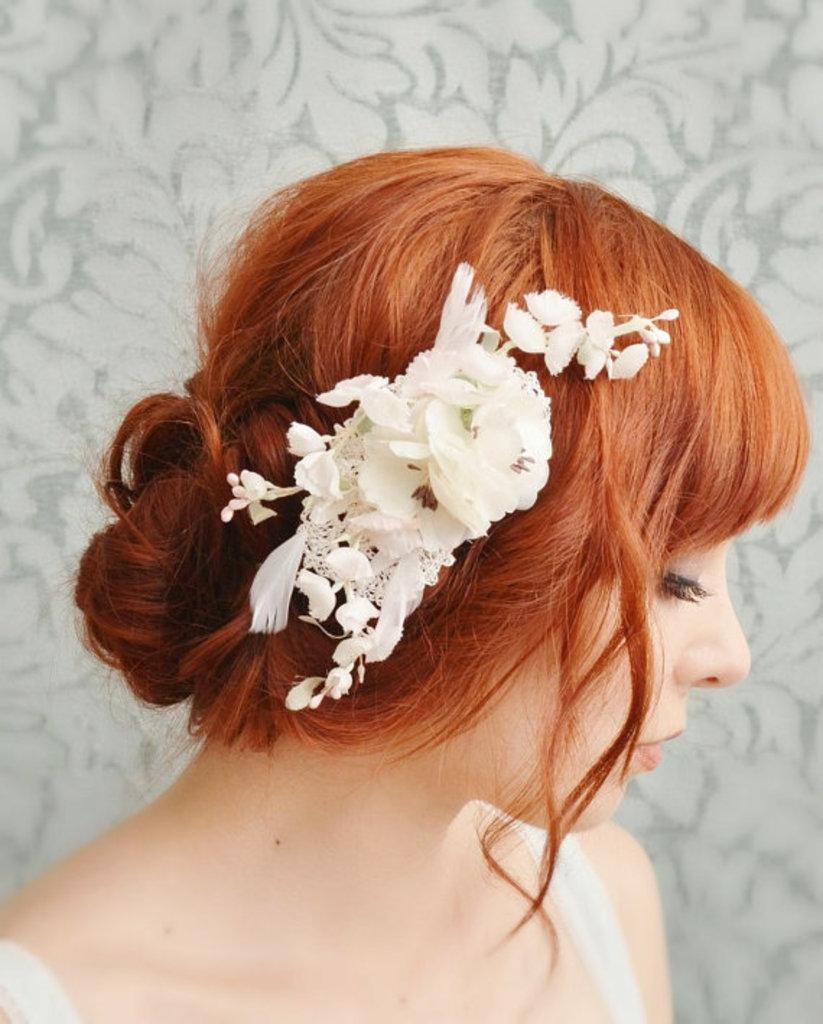Who is the main subject in the image? There is a woman in the image. What can be seen in the woman's hair? The woman has flowers in her hair. What is visible in the background of the image? There is a wall with a different design in the background of the image. What type of spark can be seen coming from the woman's head in the image? There is no spark present in the image; the woman has flowers in her hair. 